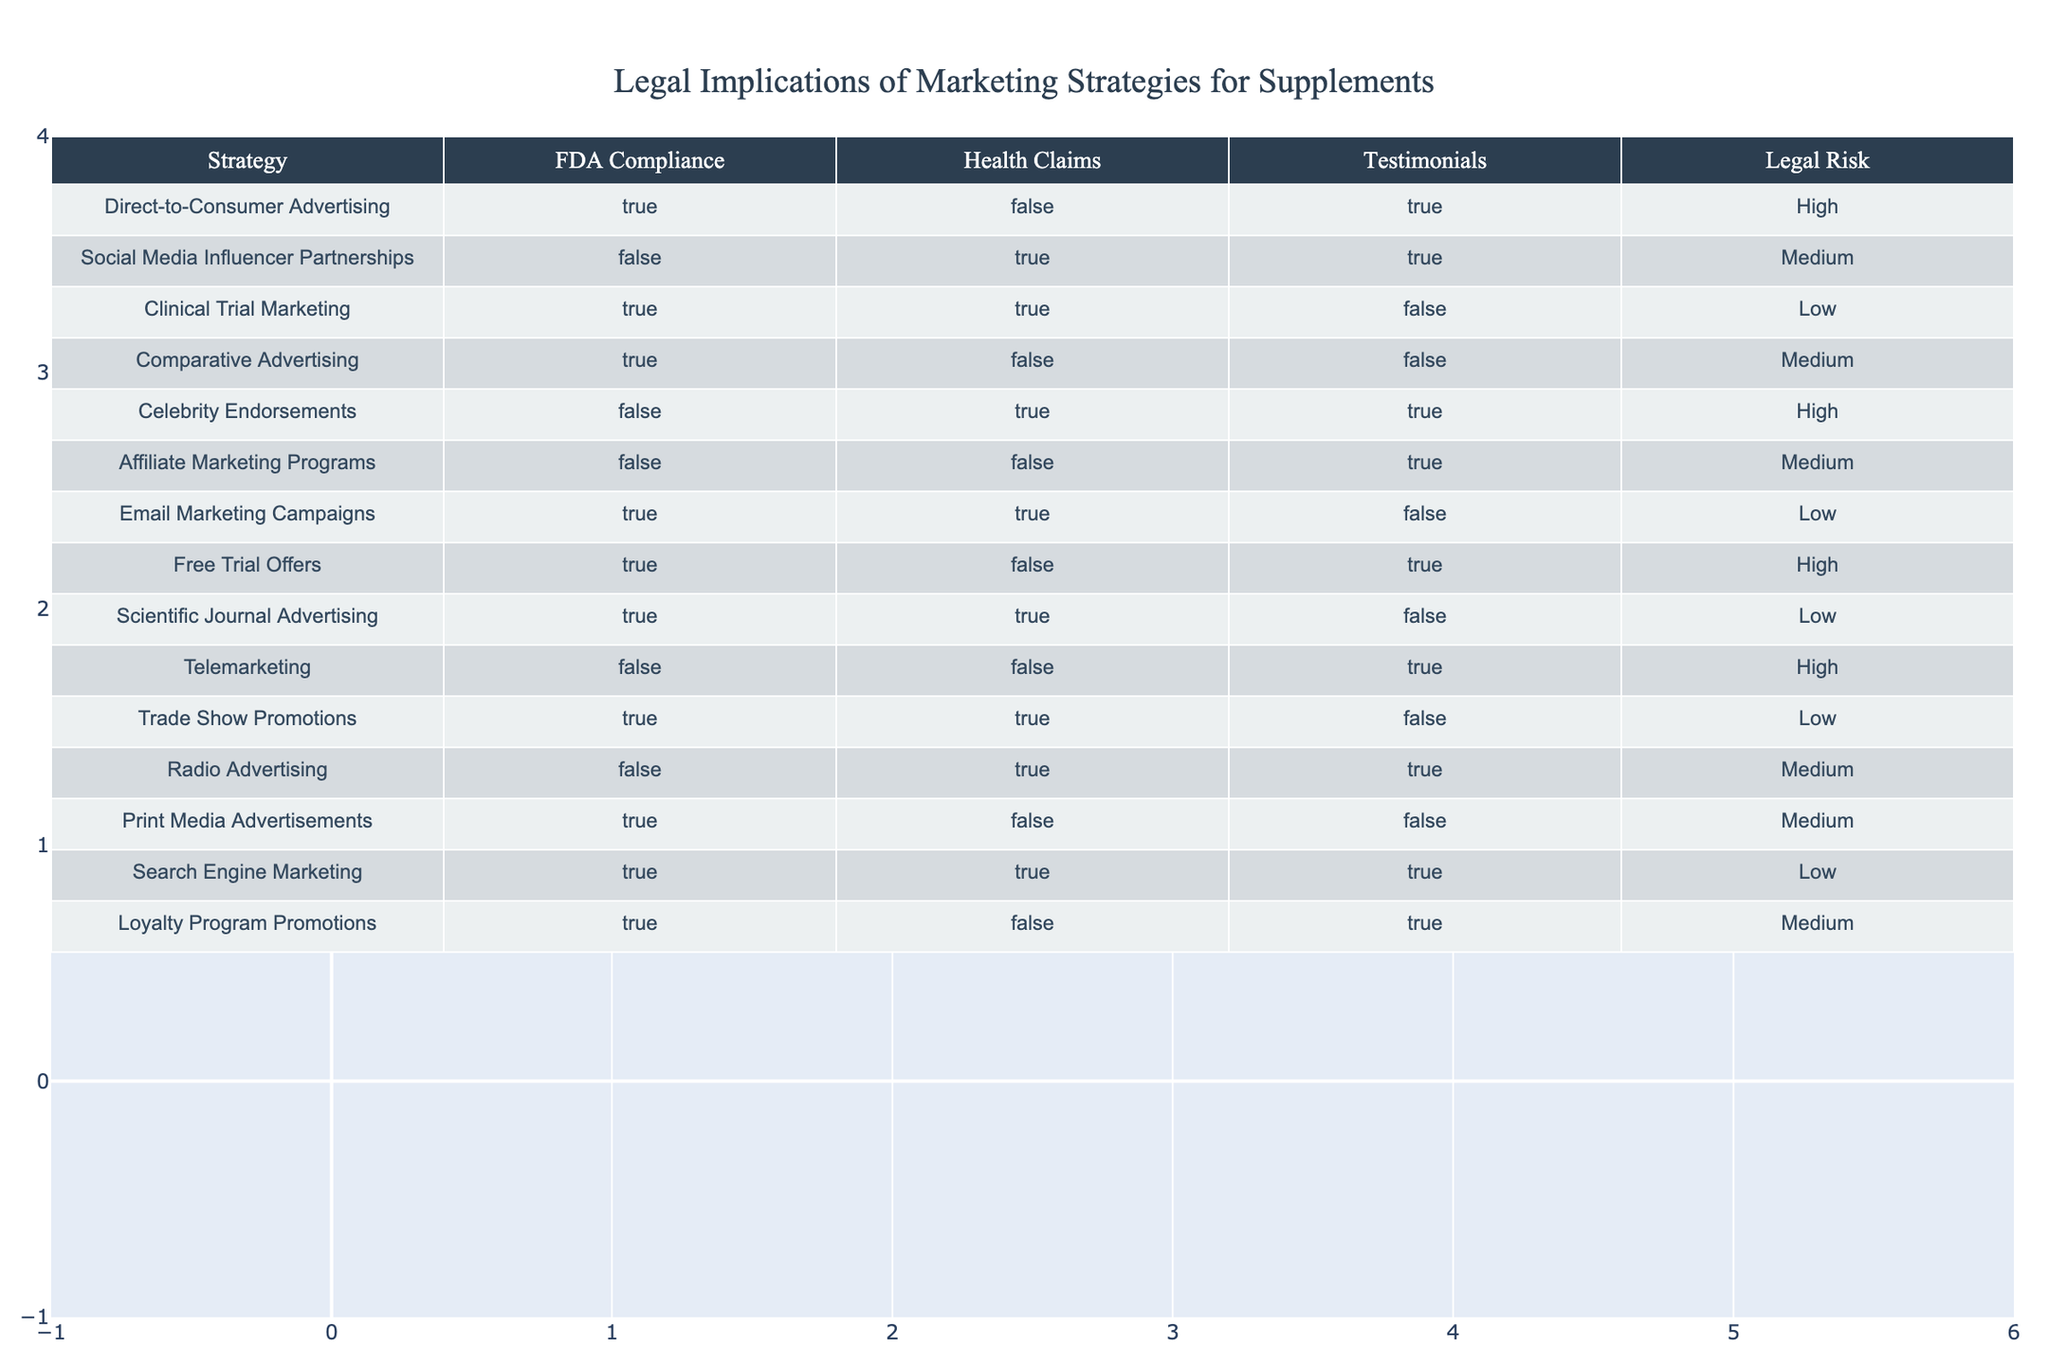What is the legal risk associated with Direct-to-Consumer Advertising? The table shows that the legal risk for Direct-to-Consumer Advertising is categorized as High. This is directly taken from the "Legal Risk" column corresponding to this strategy.
Answer: High Which marketing strategy has a low legal risk but allows for health claims? The table indicates that Clinical Trial Marketing and Email Marketing Campaigns both have a legal risk labeled as Low, and both allow for health claims. Checking each row shows that these two strategies meet the criteria.
Answer: Clinical Trial Marketing and Email Marketing Campaigns Is Social Media Influencer Partnerships FDA compliant? According to the table, Social Media Influencer Partnerships is marked as False under the FDA Compliance column. This means it does not comply with FDA regulations.
Answer: No How many marketing strategies have high legal risk? By examining the "Legal Risk" column, we can see that Direct-to-Consumer Advertising, Celebrity Endorsements, Free Trial Offers, and Telemarketing are marked as High. Counting these gives us a total of four strategies with high legal risk.
Answer: Four What proportion of the strategies allow for testimonials? To calculate this, we identify the strategies that have True for testimonials. They are Direct-to-Consumer Advertising, Social Media Influencer Partnerships, Celebrity Endorsements, Affiliate Marketing Programs, Free Trial Offers, Radio Advertising, and Loyalty Program Promotions – a total of seven strategies. With twelve total strategies, the proportion is 7/12, which is approximately 0.58 or 58%.
Answer: Approximately 58% Which strategy is the only one that is both FDA compliant and allows health claims with no testimonials? From the table, Email Marketing Campaigns is the strategy that meets all the specified criteria: it has True for FDA Compliance, True for Health Claims, and False for Testimonials, making it the only eligible strategy.
Answer: Email Marketing Campaigns Is there a marketing strategy that is FDA compliant, allows health claims, and has high legal risk? Reviewing the table shows that all strategies which are FDA compliant and allow health claims, namely Clinical Trial Marketing, Email Marketing Campaigns, Scientific Journal Advertising, and Search Engine Marketing, have a legal risk classified as Low. Therefore, there is no strategy fulfilling all three conditions.
Answer: No Why is there no marketing strategy that combines FDA compliance with celebrity endorsements? The table indicates that Celebrity Endorsements is marked as False for FDA Compliance, which eliminates it from being a strategy that is FDA compliant. Hence, no strategy can simultaneously have FDA compliance and celebrity endorsements.
Answer: Because Celebrity Endorsements is not FDA compliant 